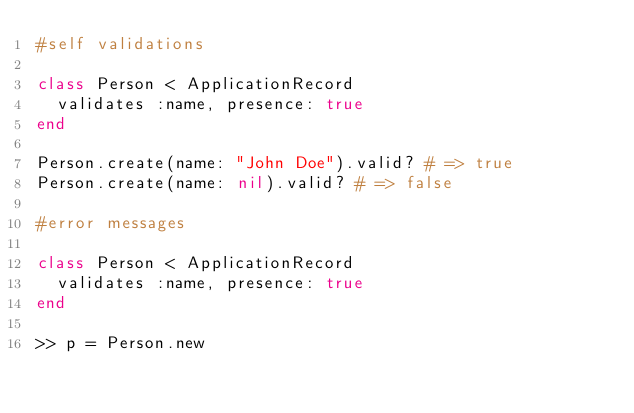<code> <loc_0><loc_0><loc_500><loc_500><_Ruby_>#self validations

class Person < ApplicationRecord
  validates :name, presence: true
end

Person.create(name: "John Doe").valid? # => true
Person.create(name: nil).valid? # => false

#error messages

class Person < ApplicationRecord
  validates :name, presence: true
end

>> p = Person.new</code> 